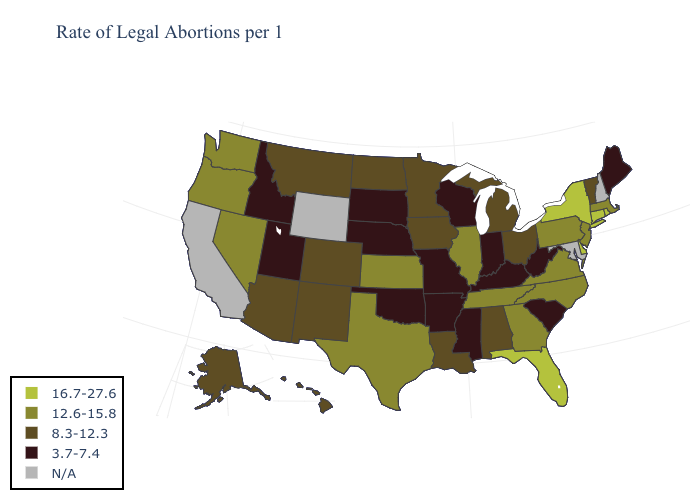Among the states that border New Jersey , which have the highest value?
Short answer required. Delaware, New York. What is the value of Idaho?
Quick response, please. 3.7-7.4. Among the states that border New Jersey , does Pennsylvania have the highest value?
Answer briefly. No. What is the value of Kentucky?
Write a very short answer. 3.7-7.4. What is the lowest value in states that border Mississippi?
Quick response, please. 3.7-7.4. What is the highest value in the South ?
Concise answer only. 16.7-27.6. What is the value of Colorado?
Give a very brief answer. 8.3-12.3. Among the states that border New Mexico , which have the lowest value?
Quick response, please. Oklahoma, Utah. Name the states that have a value in the range 3.7-7.4?
Give a very brief answer. Arkansas, Idaho, Indiana, Kentucky, Maine, Mississippi, Missouri, Nebraska, Oklahoma, South Carolina, South Dakota, Utah, West Virginia, Wisconsin. What is the value of California?
Write a very short answer. N/A. Among the states that border Florida , does Georgia have the highest value?
Short answer required. Yes. What is the lowest value in states that border Idaho?
Write a very short answer. 3.7-7.4. Does the map have missing data?
Short answer required. Yes. 